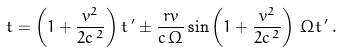Convert formula to latex. <formula><loc_0><loc_0><loc_500><loc_500>t = \left ( 1 + \frac { v ^ { 2 } } { 2 c ^ { \, 2 } } \right ) t \, ^ { \prime } \pm \frac { r v } { c \, \Omega } \sin { \left ( 1 + \frac { v ^ { 2 } } { 2 c ^ { \, 2 } } \right ) \, \Omega t \, ^ { \prime } } \, .</formula> 